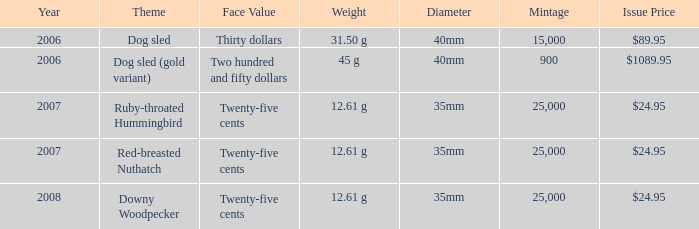What is the Mintage of the 12.61 g Weight Ruby-Throated Hummingbird? 1.0. 